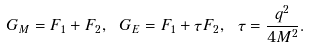Convert formula to latex. <formula><loc_0><loc_0><loc_500><loc_500>G _ { M } = F _ { 1 } + F _ { 2 } , \ G _ { E } = F _ { 1 } + \tau F _ { 2 } , \ \tau = \frac { q ^ { 2 } } { 4 M ^ { 2 } } .</formula> 